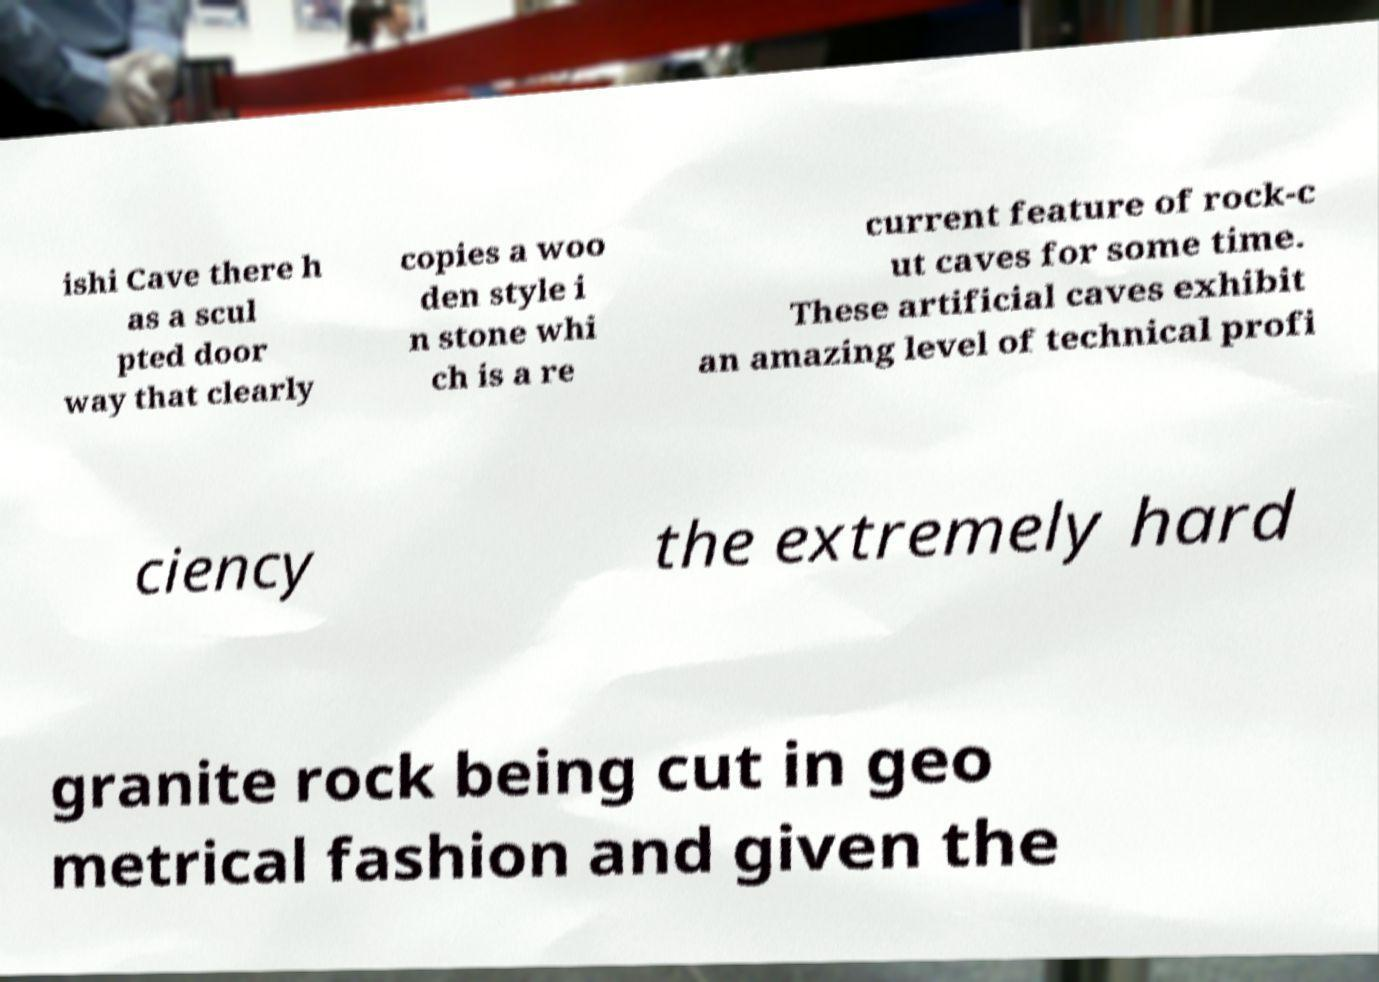Could you extract and type out the text from this image? ishi Cave there h as a scul pted door way that clearly copies a woo den style i n stone whi ch is a re current feature of rock-c ut caves for some time. These artificial caves exhibit an amazing level of technical profi ciency the extremely hard granite rock being cut in geo metrical fashion and given the 